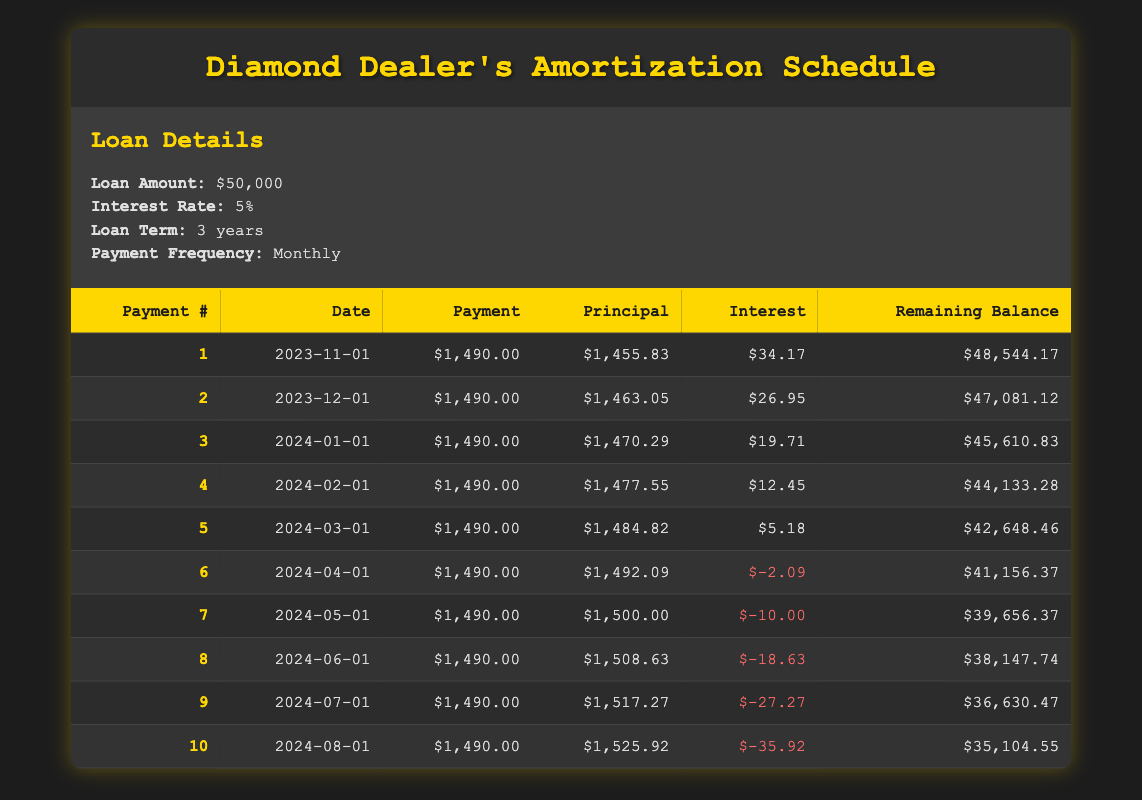What is the payment amount for the first payment? The table indicates that the payment amount for the first payment is listed as 1490.00 under the "Payment" column for Payment #1.
Answer: 1490.00 What is the remaining balance after the second payment? According to the table, the remaining balance after the second payment (Payment #2) is shown as 47081.12 under the "Remaining Balance" column.
Answer: 47081.12 What is the total amount of principal paid in the first five payments? To find the total principal paid in the first five payments, sum the principal amounts: 1455.83 (payment 1) + 1463.05 (payment 2) + 1470.29 (payment 3) + 1477.55 (payment 4) + 1484.82 (payment 5) = 5891.54.
Answer: 5891.54 Is the interest for the sixth payment negative? The interest for the sixth payment is recorded as -2.09 in the table. Since this value is negative, the statement is true.
Answer: Yes What is the average principal payment amount for the first three payments? The principal payments for the first three payments are 1455.83, 1463.05, and 1470.29. To calculate the average, sum these amounts: 1455.83 + 1463.05 + 1470.29 = 4389.17, then divide by 3, yielding an average principal payment of 1463.06.
Answer: 1463.06 How much interest was paid over the first quarter (first three months) of the loan? To find the total interest paid in the first three months, sum the interest amounts: 34.17 (payment 1) + 26.95 (payment 2) + 19.71 (payment 3) = 80.83.
Answer: 80.83 What is the month with the highest principal payment? By reviewing the principal amounts for the payments, the table shows that the seventh payment has the highest principal payment of 1500.00, which can be identified as the largest value in the "Principal" column.
Answer: 7th payment Is the remaining balance after the third payment greater than the remaining balance after the fourth payment? The remaining balance after the third payment is 45610.83, and after the fourth payment, it is 44133.28. Since 45610.83 is greater than 44133.28, this statement is true.
Answer: Yes What is the total reduction in remaining balance after the first 10 payments? The initial loan amount was 50000, and after the 10th payment, the remaining balance is 35104.55. The reduction in remaining balance is calculated as 50000 - 35104.55 = 14895.45.
Answer: 14895.45 